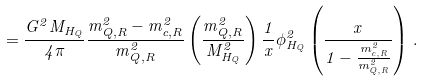Convert formula to latex. <formula><loc_0><loc_0><loc_500><loc_500>= \frac { G ^ { 2 } M _ { H _ { Q } } } { 4 \pi } \frac { m _ { Q , R } ^ { 2 } - m _ { c , R } ^ { 2 } } { m ^ { 2 } _ { Q , R } } \left ( \frac { m ^ { 2 } _ { Q , R } } { M ^ { 2 } _ { H _ { Q } } } \right ) \frac { 1 } { x } \phi _ { H _ { Q } } ^ { 2 } \left ( \frac { x } { 1 - \frac { m _ { c , R } ^ { 2 } } { m _ { Q , R } ^ { 2 } } } \right ) \, .</formula> 